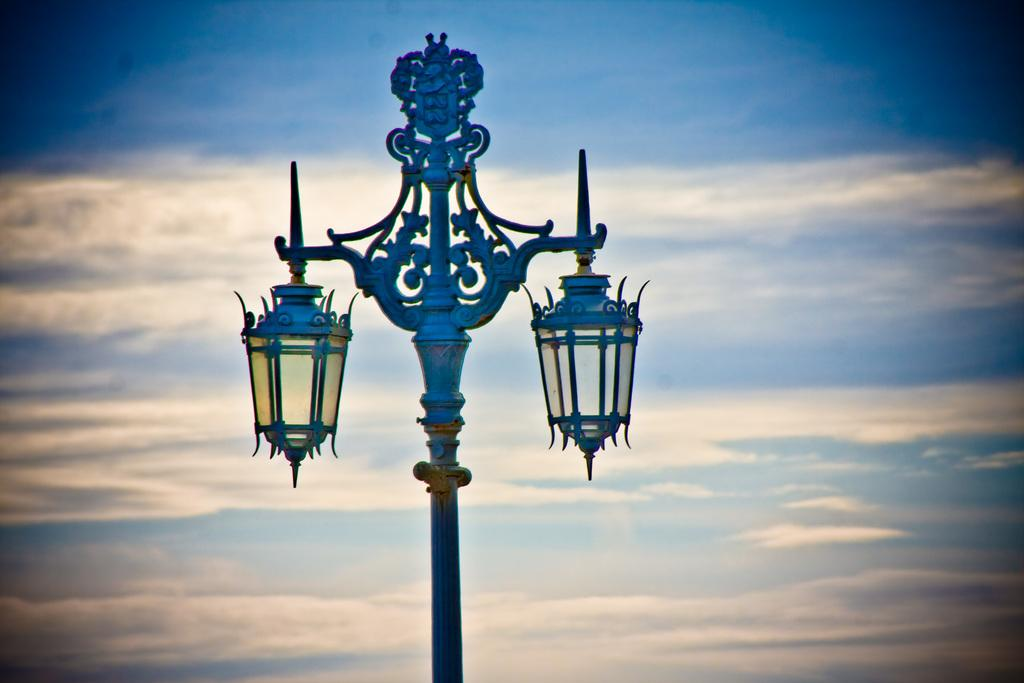What is the main object in the image? There is a pole in the image. What else can be seen in the image besides the pole? There are lamps in the image. What can be seen in the background of the image? The sky is visible in the background of the image. How much waste is visible in the image? There is no waste visible in the image; it only features a pole, lamps, and the sky. 